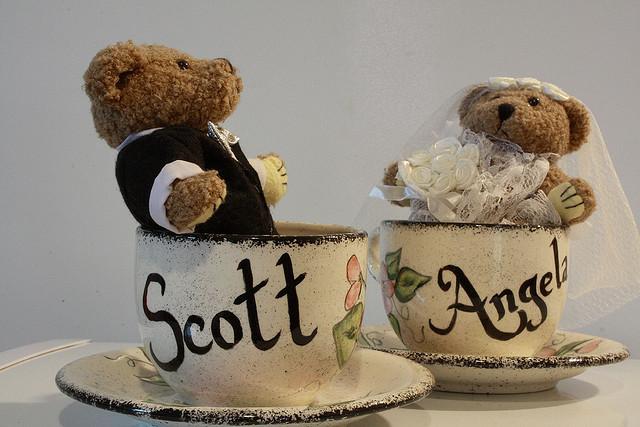What is the groom's name?
Short answer required. Scott. What is the bear's message?
Short answer required. Scott. What does the cup on the right read?
Quick response, please. Angela. Do you think Angela and Scott are married?
Answer briefly. Yes. 